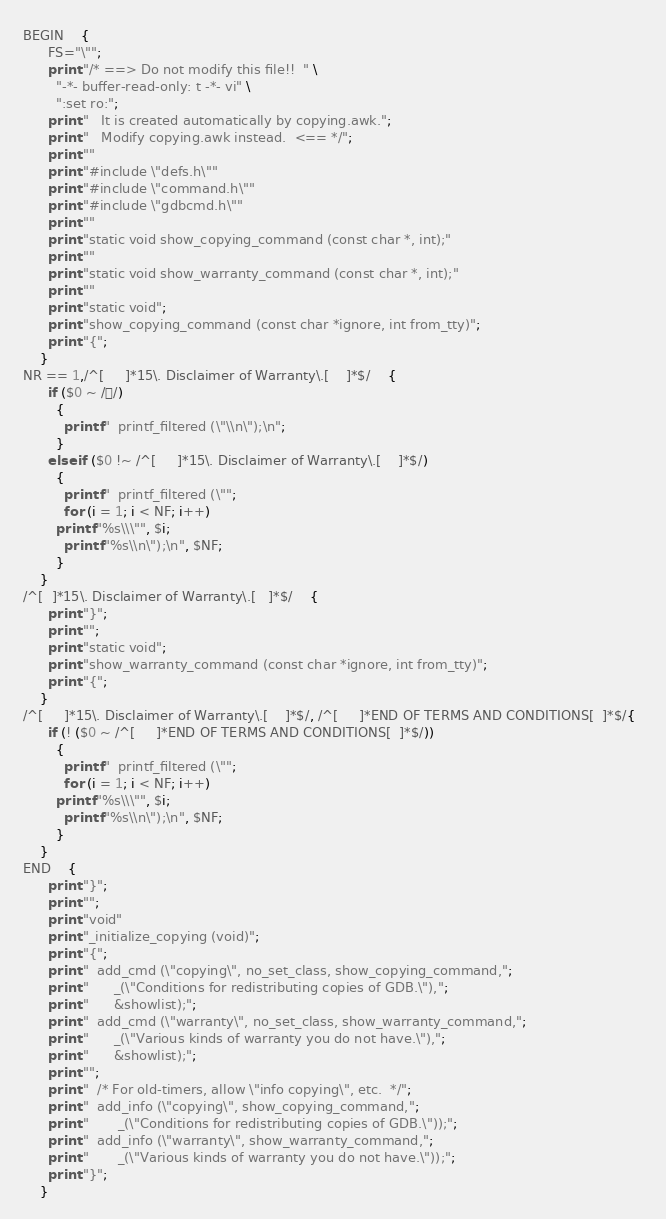Convert code to text. <code><loc_0><loc_0><loc_500><loc_500><_Awk_>BEGIN	{
	  FS="\"";
	  print "/* ==> Do not modify this file!!  " \
		"-*- buffer-read-only: t -*- vi" \
		":set ro:";
	  print "   It is created automatically by copying.awk.";
	  print "   Modify copying.awk instead.  <== */";
	  print ""
	  print "#include \"defs.h\""
	  print "#include \"command.h\""
	  print "#include \"gdbcmd.h\""
	  print ""
	  print "static void show_copying_command (const char *, int);"
	  print ""
	  print "static void show_warranty_command (const char *, int);"
	  print ""
	  print "static void";
	  print "show_copying_command (const char *ignore, int from_tty)";
	  print "{";
	}
NR == 1,/^[ 	]*15\. Disclaimer of Warranty\.[ 	]*$/	{
	  if ($0 ~ //)
	    {
	      printf "  printf_filtered (\"\\n\");\n";
	    }
	  else if ($0 !~ /^[ 	]*15\. Disclaimer of Warranty\.[ 	]*$/) 
	    {
	      printf "  printf_filtered (\"";
	      for (i = 1; i < NF; i++)
		printf "%s\\\"", $i;
	      printf "%s\\n\");\n", $NF;
	    }
	}
/^[	 ]*15\. Disclaimer of Warranty\.[ 	]*$/	{
	  print "}";
	  print "";
	  print "static void";
	  print "show_warranty_command (const char *ignore, int from_tty)";
	  print "{";
	}
/^[ 	]*15\. Disclaimer of Warranty\.[ 	]*$/, /^[ 	]*END OF TERMS AND CONDITIONS[ 	]*$/{  
	  if (! ($0 ~ /^[ 	]*END OF TERMS AND CONDITIONS[ 	]*$/)) 
	    {
	      printf "  printf_filtered (\"";
	      for (i = 1; i < NF; i++)
		printf "%s\\\"", $i;
	      printf "%s\\n\");\n", $NF;
	    }
	}
END	{
	  print "}";
	  print "";
	  print "void"
	  print "_initialize_copying (void)";
	  print "{";
	  print "  add_cmd (\"copying\", no_set_class, show_copying_command,";
	  print "	   _(\"Conditions for redistributing copies of GDB.\"),";
	  print "	   &showlist);";
	  print "  add_cmd (\"warranty\", no_set_class, show_warranty_command,";
	  print "	   _(\"Various kinds of warranty you do not have.\"),";
	  print "	   &showlist);";
	  print "";
	  print "  /* For old-timers, allow \"info copying\", etc.  */";
	  print "  add_info (\"copying\", show_copying_command,";
	  print "	    _(\"Conditions for redistributing copies of GDB.\"));";
	  print "  add_info (\"warranty\", show_warranty_command,";
	  print "	    _(\"Various kinds of warranty you do not have.\"));";
	  print "}";
	}
</code> 